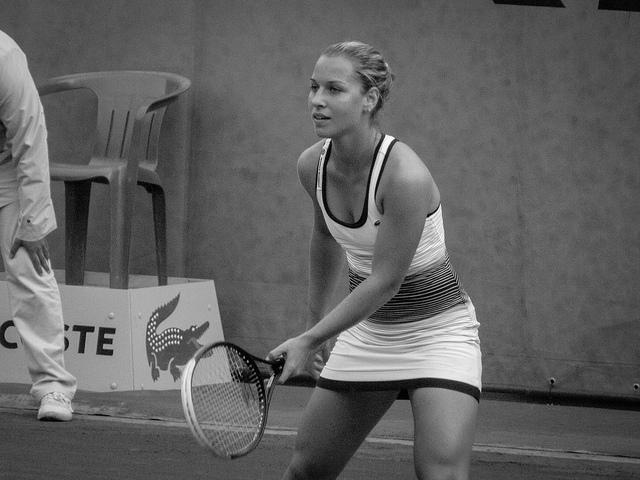How many people are there?
Give a very brief answer. 2. How many tennis rackets are there?
Give a very brief answer. 1. 